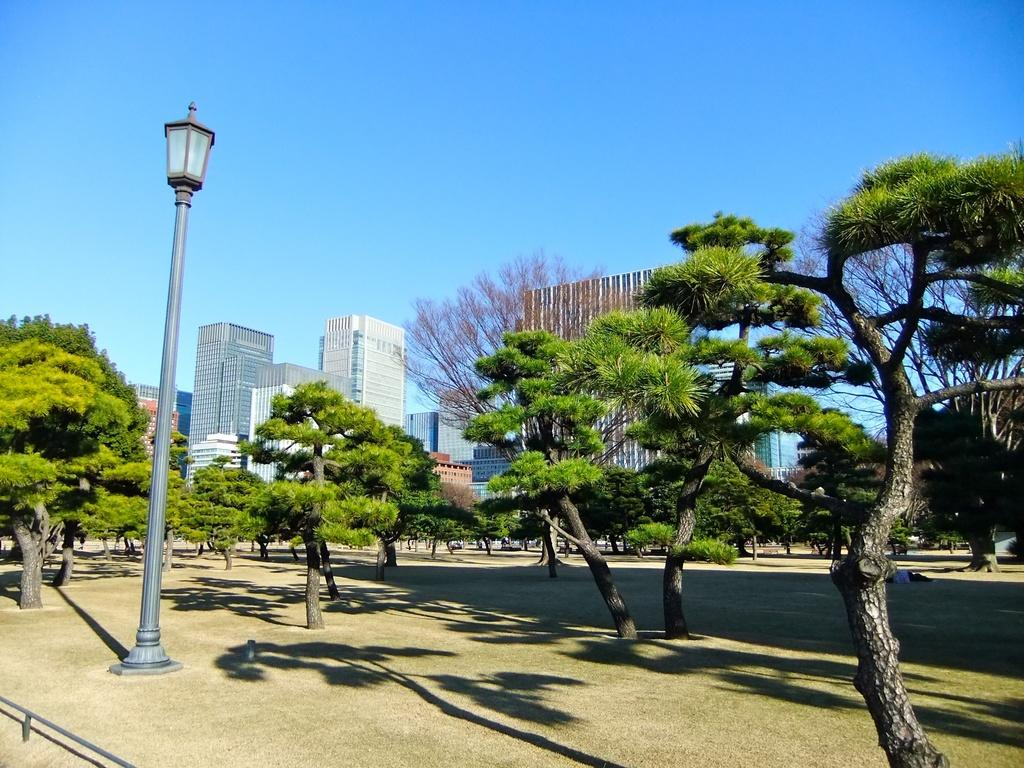What type of surface is visible in the image? There is ground visible in the image. What can be found on the ground in the image? There are trees on the ground in the image. What is the tall structure with a light in the image? There is a light pole in the image. What can be seen in the distance behind the trees and light pole? There are buildings in the background of the image. What color is the sky in the background of the image? The sky is blue in the background of the image. What type of joke is being told by the stem of the tree in the image? There is no joke being told by the stem of the tree in the image, as trees do not have the ability to tell jokes. 